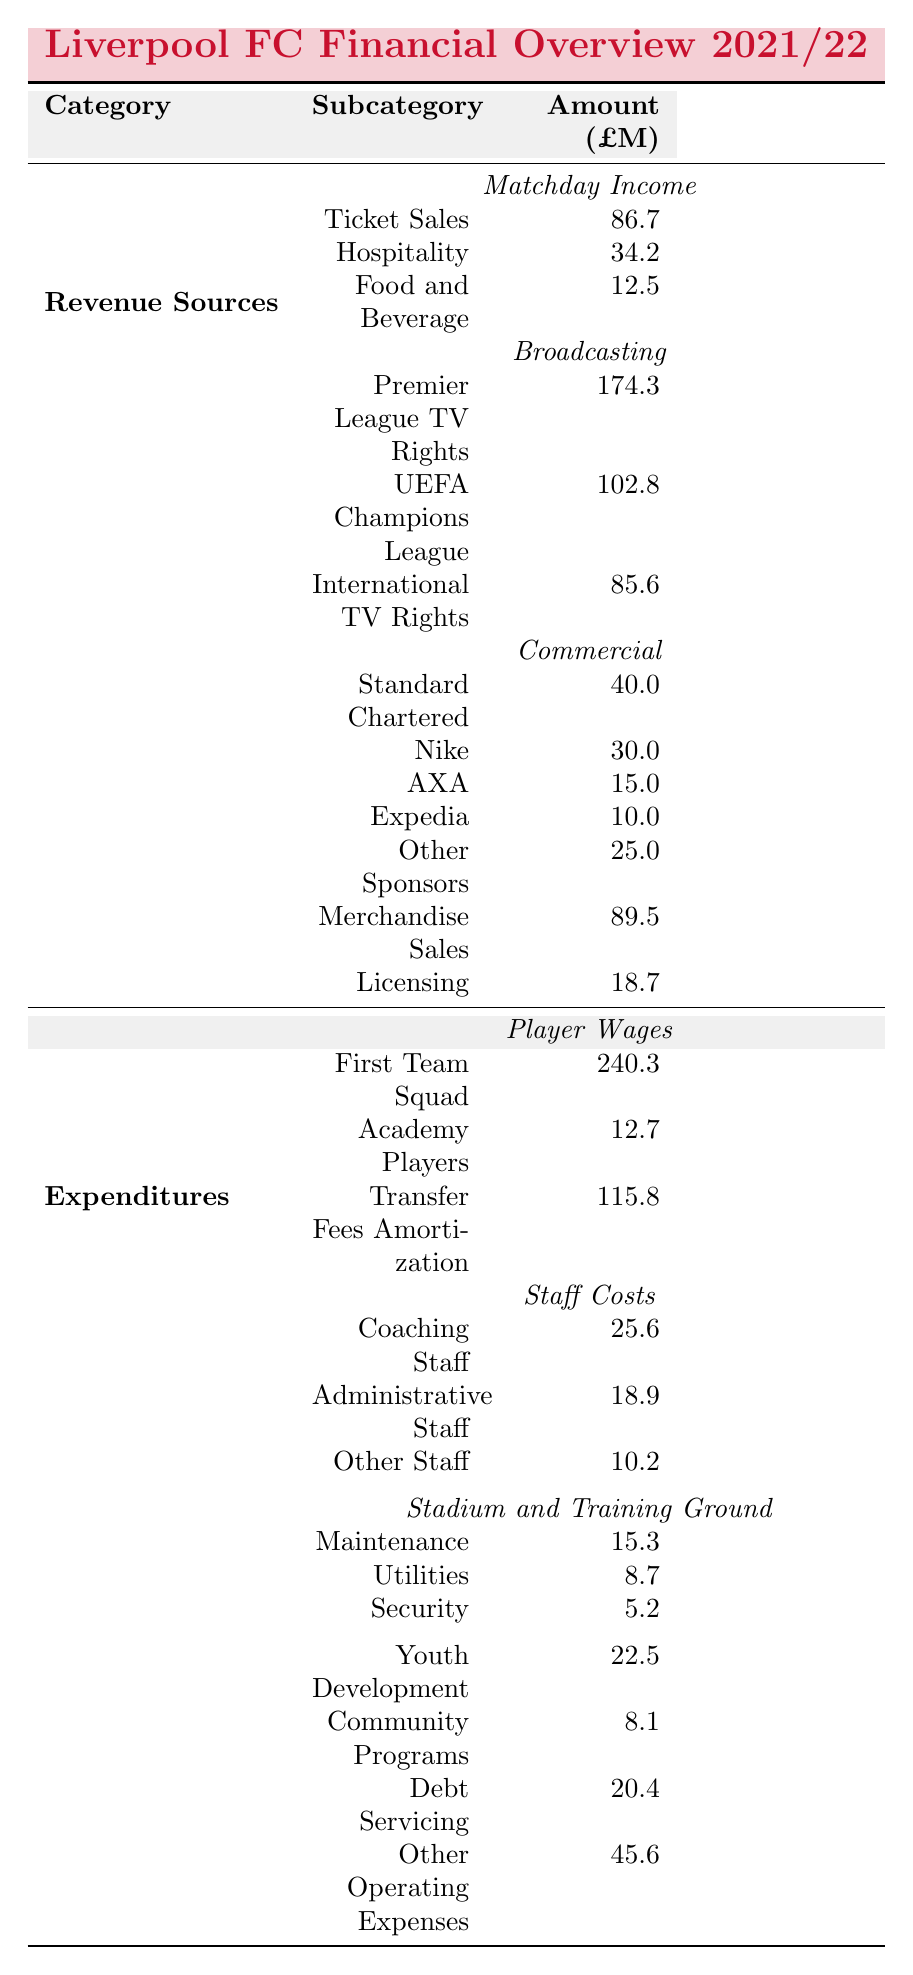What is the total Matchday Income for Liverpool FC? To find the total Matchday Income, sum the individual components: Ticket Sales (86.7), Hospitality (34.2), and Food and Beverage (12.5). The total is 86.7 + 34.2 + 12.5 = 133.4.
Answer: 133.4 How much revenue does Liverpool FC generate from Premier League TV Rights? The table directly states the value for Premier League TV Rights as 174.3.
Answer: 174.3 Which has a higher expenditure: Player Wages or Transfer Fees Amortization? Player Wages total 253.0 (240.3 for First Team Squad + 12.7 for Academy Players) and Transfer Fees Amortization is 115.8. Since 253.0 is greater than 115.8, Player Wages has a higher expenditure.
Answer: Player Wages What is the total revenue from Commercial sources? To find total revenue from Commercial sources, add the values for Sponsorships (sum of all sponsors: 40.0, 30.0, 15.0, 10.0, 25.0) plus Merchandise Sales (89.5) and Licensing (18.7). The total is (40.0 + 30.0 + 15.0 + 10.0 + 25.0 + 89.5 + 18.7) = 228.2.
Answer: 228.2 Is the expenditure on Youth Development greater than on Community Programs? The expenditure on Youth Development is 22.5, and on Community Programs, it is 8.1. Since 22.5 is greater than 8.1, the statement is true.
Answer: Yes How much does Liverpool FC spend on staff in total? The total staff costs include Coaching Staff (25.6), Administrative Staff (18.9), and Other Staff (10.2). So the total is 25.6 + 18.9 + 10.2 = 54.7.
Answer: 54.7 What percentage of the total revenue is derived from Broadcasting sources? The total revenue from Broadcasting sources is the sum of Premier League TV Rights (174.3), UEFA Champions League (102.8), and International TV Rights (85.6), giving a total of 362.7. Then, the total revenue from all sources is 133.4 (Matchday) + 362.7 (Broadcasting) + 228.2 (Commercial) = 724.3. The percentage is (362.7/724.3) * 100 ≈ 50.1%.
Answer: 50.1% What is the total expenditure on stadium and training ground maintenance? This includes Maintenance (15.3), Utilities (8.7), and Security (5.2). Therefore, the total expenditure is 15.3 + 8.7 + 5.2 = 29.2.
Answer: 29.2 Which category has the highest revenue source, and how much is it? Broadcasting has the highest revenue source with a total of 362.7 (sum of Premier League TV Rights, UEFA Champions League, and International TV Rights), which is higher than Matchday Income (133.4) and Commercial (228.2).
Answer: Broadcasting, 362.7 What is the difference between total revenue and total expenditures for Liverpool FC? Total revenue is 724.3 and total expenditures are 405.9 (sum of all expenditure categories). The difference is 724.3 - 405.9 = 318.4.
Answer: 318.4 